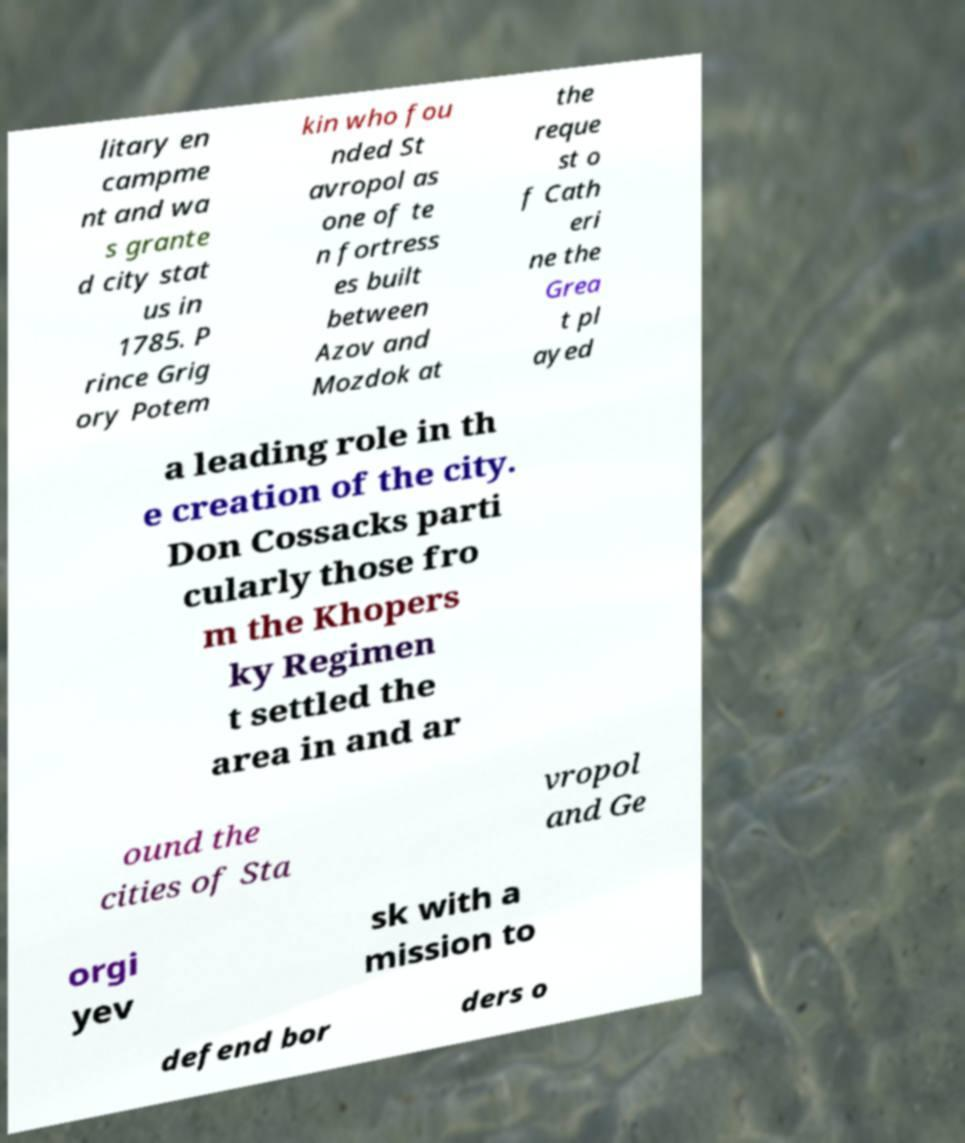Can you read and provide the text displayed in the image?This photo seems to have some interesting text. Can you extract and type it out for me? litary en campme nt and wa s grante d city stat us in 1785. P rince Grig ory Potem kin who fou nded St avropol as one of te n fortress es built between Azov and Mozdok at the reque st o f Cath eri ne the Grea t pl ayed a leading role in th e creation of the city. Don Cossacks parti cularly those fro m the Khopers ky Regimen t settled the area in and ar ound the cities of Sta vropol and Ge orgi yev sk with a mission to defend bor ders o 